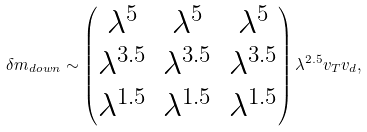Convert formula to latex. <formula><loc_0><loc_0><loc_500><loc_500>\delta m _ { d o w n } \sim \begin{pmatrix} \lambda ^ { 5 } & \lambda ^ { 5 } & \lambda ^ { 5 } \\ \lambda ^ { 3 . 5 } & \lambda ^ { 3 . 5 } & \lambda ^ { 3 . 5 } \\ \lambda ^ { 1 . 5 } & \lambda ^ { 1 . 5 } & \lambda ^ { 1 . 5 } \end{pmatrix} \lambda ^ { 2 . 5 } v _ { T } v _ { d } ,</formula> 